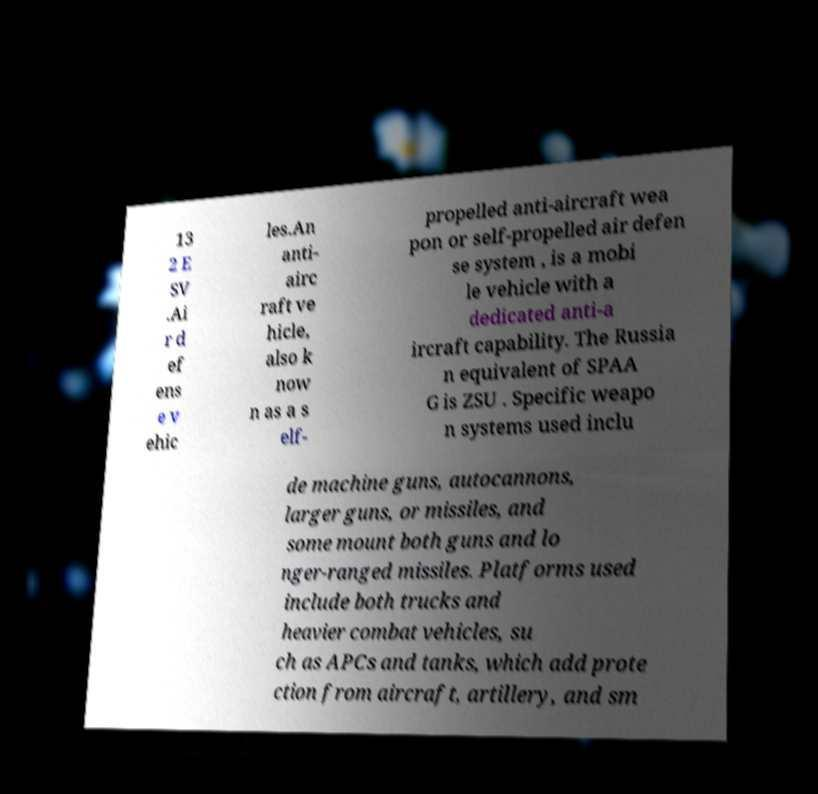Could you assist in decoding the text presented in this image and type it out clearly? 13 2 E SV .Ai r d ef ens e v ehic les.An anti- airc raft ve hicle, also k now n as a s elf- propelled anti-aircraft wea pon or self-propelled air defen se system , is a mobi le vehicle with a dedicated anti-a ircraft capability. The Russia n equivalent of SPAA G is ZSU . Specific weapo n systems used inclu de machine guns, autocannons, larger guns, or missiles, and some mount both guns and lo nger-ranged missiles. Platforms used include both trucks and heavier combat vehicles, su ch as APCs and tanks, which add prote ction from aircraft, artillery, and sm 